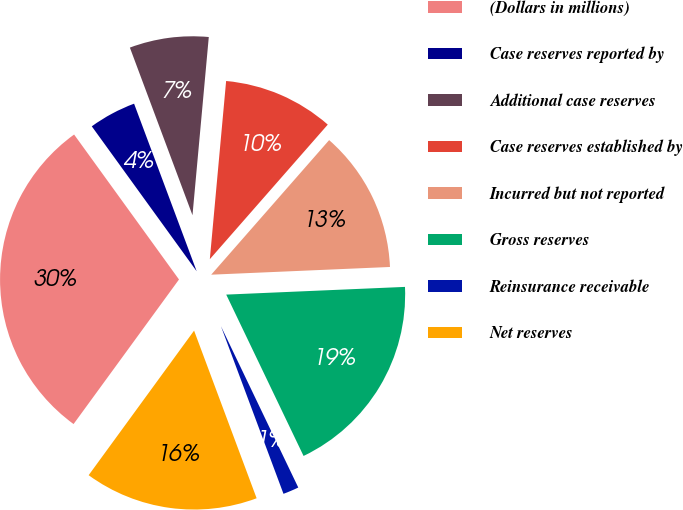<chart> <loc_0><loc_0><loc_500><loc_500><pie_chart><fcel>(Dollars in millions)<fcel>Case reserves reported by<fcel>Additional case reserves<fcel>Case reserves established by<fcel>Incurred but not reported<fcel>Gross reserves<fcel>Reinsurance receivable<fcel>Net reserves<nl><fcel>30.0%<fcel>4.28%<fcel>7.14%<fcel>10.0%<fcel>12.86%<fcel>18.57%<fcel>1.43%<fcel>15.71%<nl></chart> 